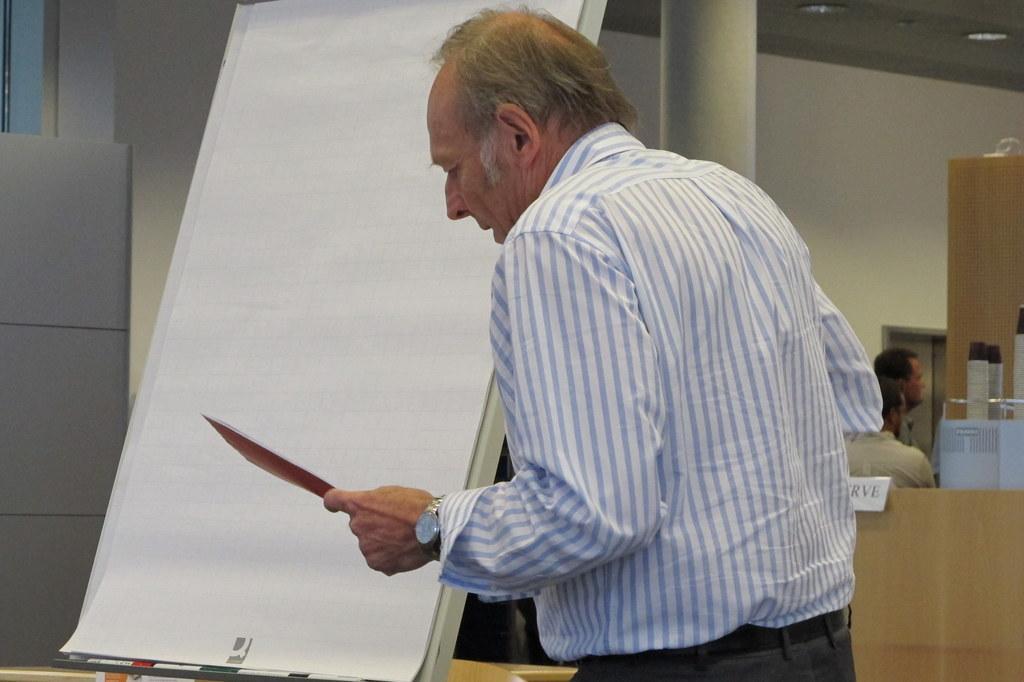Please provide a concise description of this image. In this image we can see a man standing holding a paper. We can also see a pillar, some papers on a board, a name board, some people sitting, a door, a wooden container, a wall and a roof with some ceiling lights. 